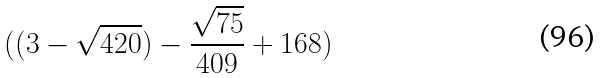<formula> <loc_0><loc_0><loc_500><loc_500>( ( 3 - \sqrt { 4 2 0 } ) - \frac { \sqrt { 7 5 } } { 4 0 9 } + 1 6 8 )</formula> 